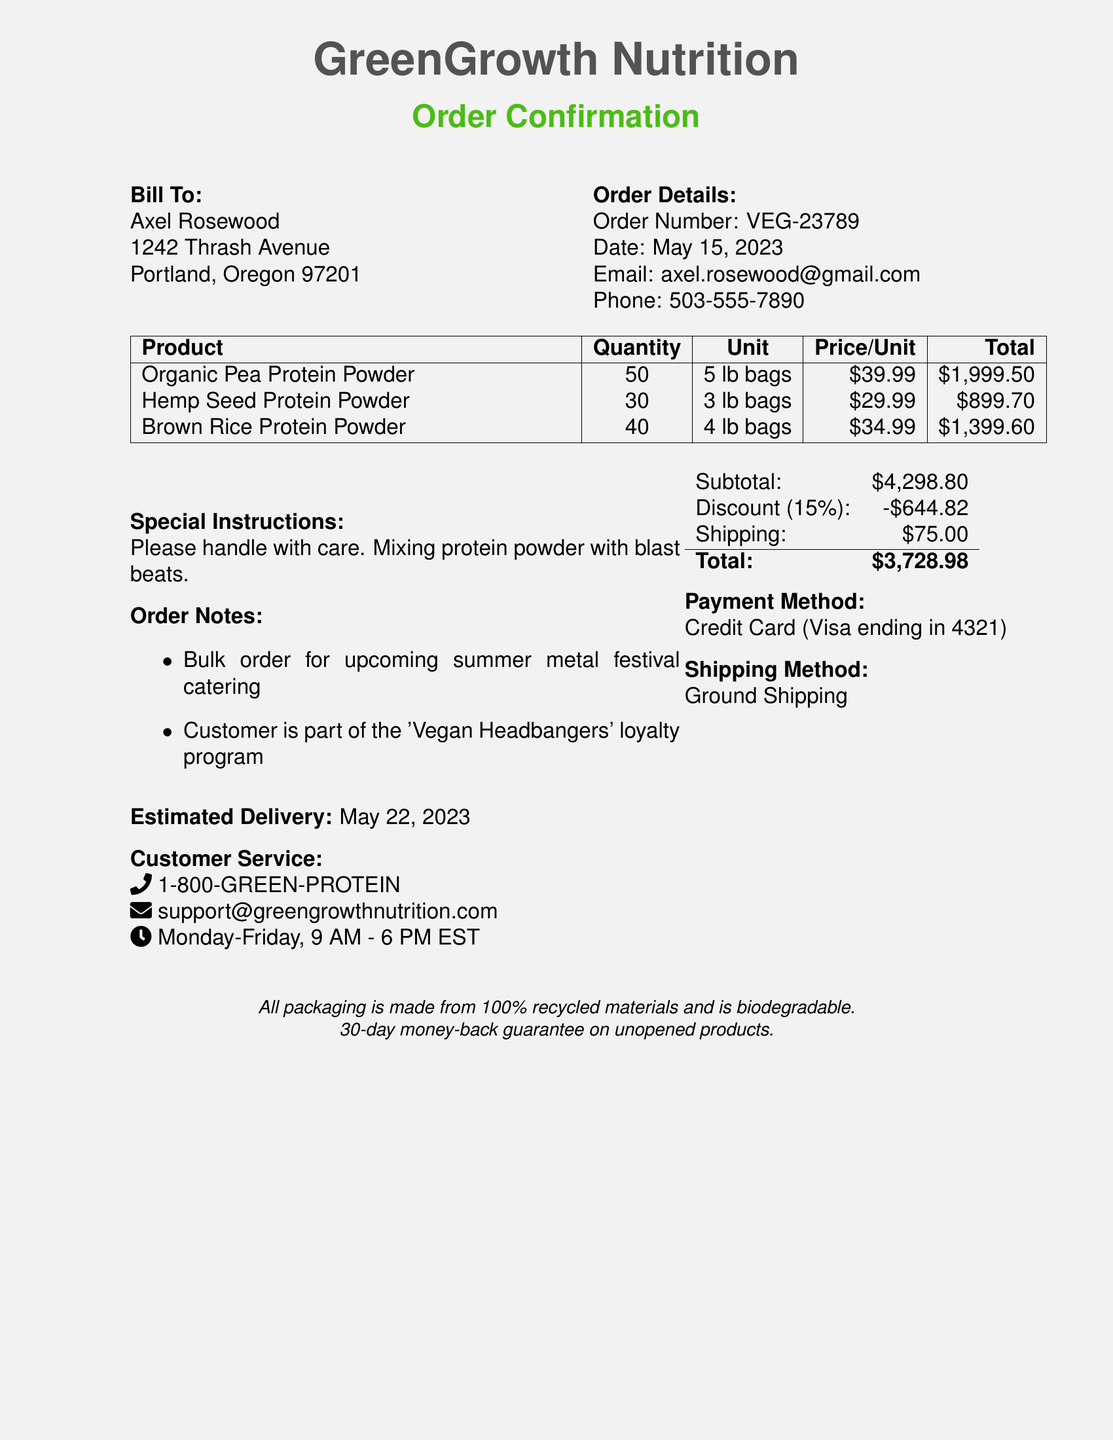What is the order number? The order number can be found in the order details section of the document.
Answer: VEG-23789 What is the total amount after discount? The total amount after discount is provided at the end of the order summary.
Answer: $3,728.98 What shipping method is used? The shipping method is listed in the order summary.
Answer: Ground Shipping What discount percentage applies for a bulk order of 100 units? The discount percentage is specified in the quantity discounts section.
Answer: 10% What is the estimated delivery date? The estimated delivery date is stated in the order details.
Answer: May 22, 2023 Who is the customer? The customer name is mentioned at the beginning of the document.
Answer: Axel Rosewood What is the total quantity of protein powder ordered? The total quantity is the sum of all product quantities in the order.
Answer: 120 What special instructions were included in the order? Special instructions are provided in the order summary section.
Answer: Please handle with care. Mixing protein powder with blast beats What is the return policy? The return policy is noted at the bottom of the document.
Answer: 30-day money-back guarantee on unopened products What type of program is the customer part of? The loyalty program is mentioned in the order notes.
Answer: Vegan Headbangers 